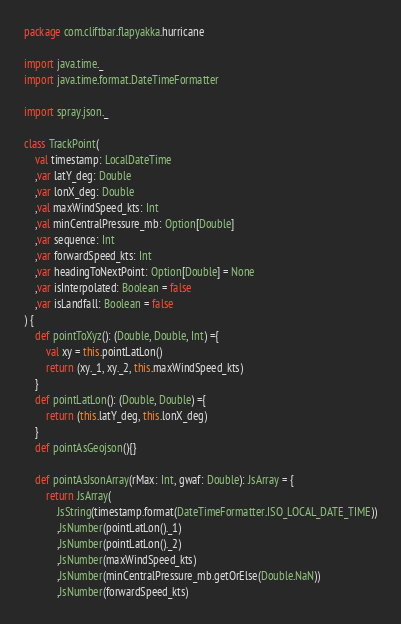Convert code to text. <code><loc_0><loc_0><loc_500><loc_500><_Scala_>package com.cliftbar.flapyakka.hurricane

import java.time._
import java.time.format.DateTimeFormatter

import spray.json._

class TrackPoint(
    val timestamp: LocalDateTime
    ,var latY_deg: Double
    ,var lonX_deg: Double
    ,val maxWindSpeed_kts: Int
    ,val minCentralPressure_mb: Option[Double]
    ,var sequence: Int
    ,var forwardSpeed_kts: Int
    ,var headingToNextPoint: Option[Double] = None
    ,var isInterpolated: Boolean = false
    ,var isLandfall: Boolean = false
) {
    def pointToXyz(): (Double, Double, Int) ={
        val xy = this.pointLatLon()
        return (xy._1, xy._2, this.maxWindSpeed_kts)
    }
    def pointLatLon(): (Double, Double) ={
        return (this.latY_deg, this.lonX_deg)
    }
    def pointAsGeojson(){}

    def pointAsJsonArray(rMax: Int, gwaf: Double): JsArray = {
        return JsArray(
            JsString(timestamp.format(DateTimeFormatter.ISO_LOCAL_DATE_TIME))
            ,JsNumber(pointLatLon()._1)
            ,JsNumber(pointLatLon()._2)
            ,JsNumber(maxWindSpeed_kts)
            ,JsNumber(minCentralPressure_mb.getOrElse(Double.NaN))
            ,JsNumber(forwardSpeed_kts)</code> 